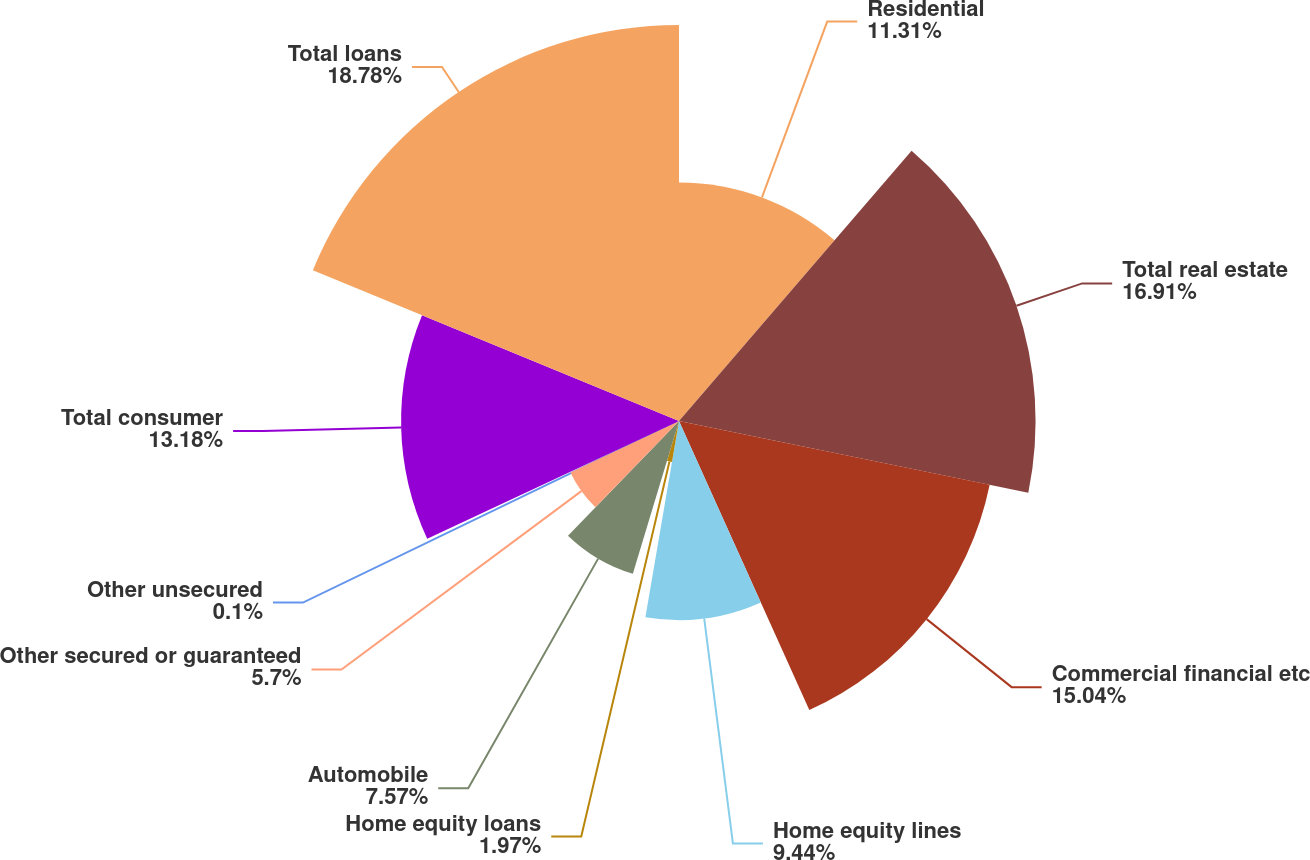Convert chart to OTSL. <chart><loc_0><loc_0><loc_500><loc_500><pie_chart><fcel>Residential<fcel>Total real estate<fcel>Commercial financial etc<fcel>Home equity lines<fcel>Home equity loans<fcel>Automobile<fcel>Other secured or guaranteed<fcel>Other unsecured<fcel>Total consumer<fcel>Total loans<nl><fcel>11.31%<fcel>16.91%<fcel>15.04%<fcel>9.44%<fcel>1.97%<fcel>7.57%<fcel>5.7%<fcel>0.1%<fcel>13.18%<fcel>18.78%<nl></chart> 